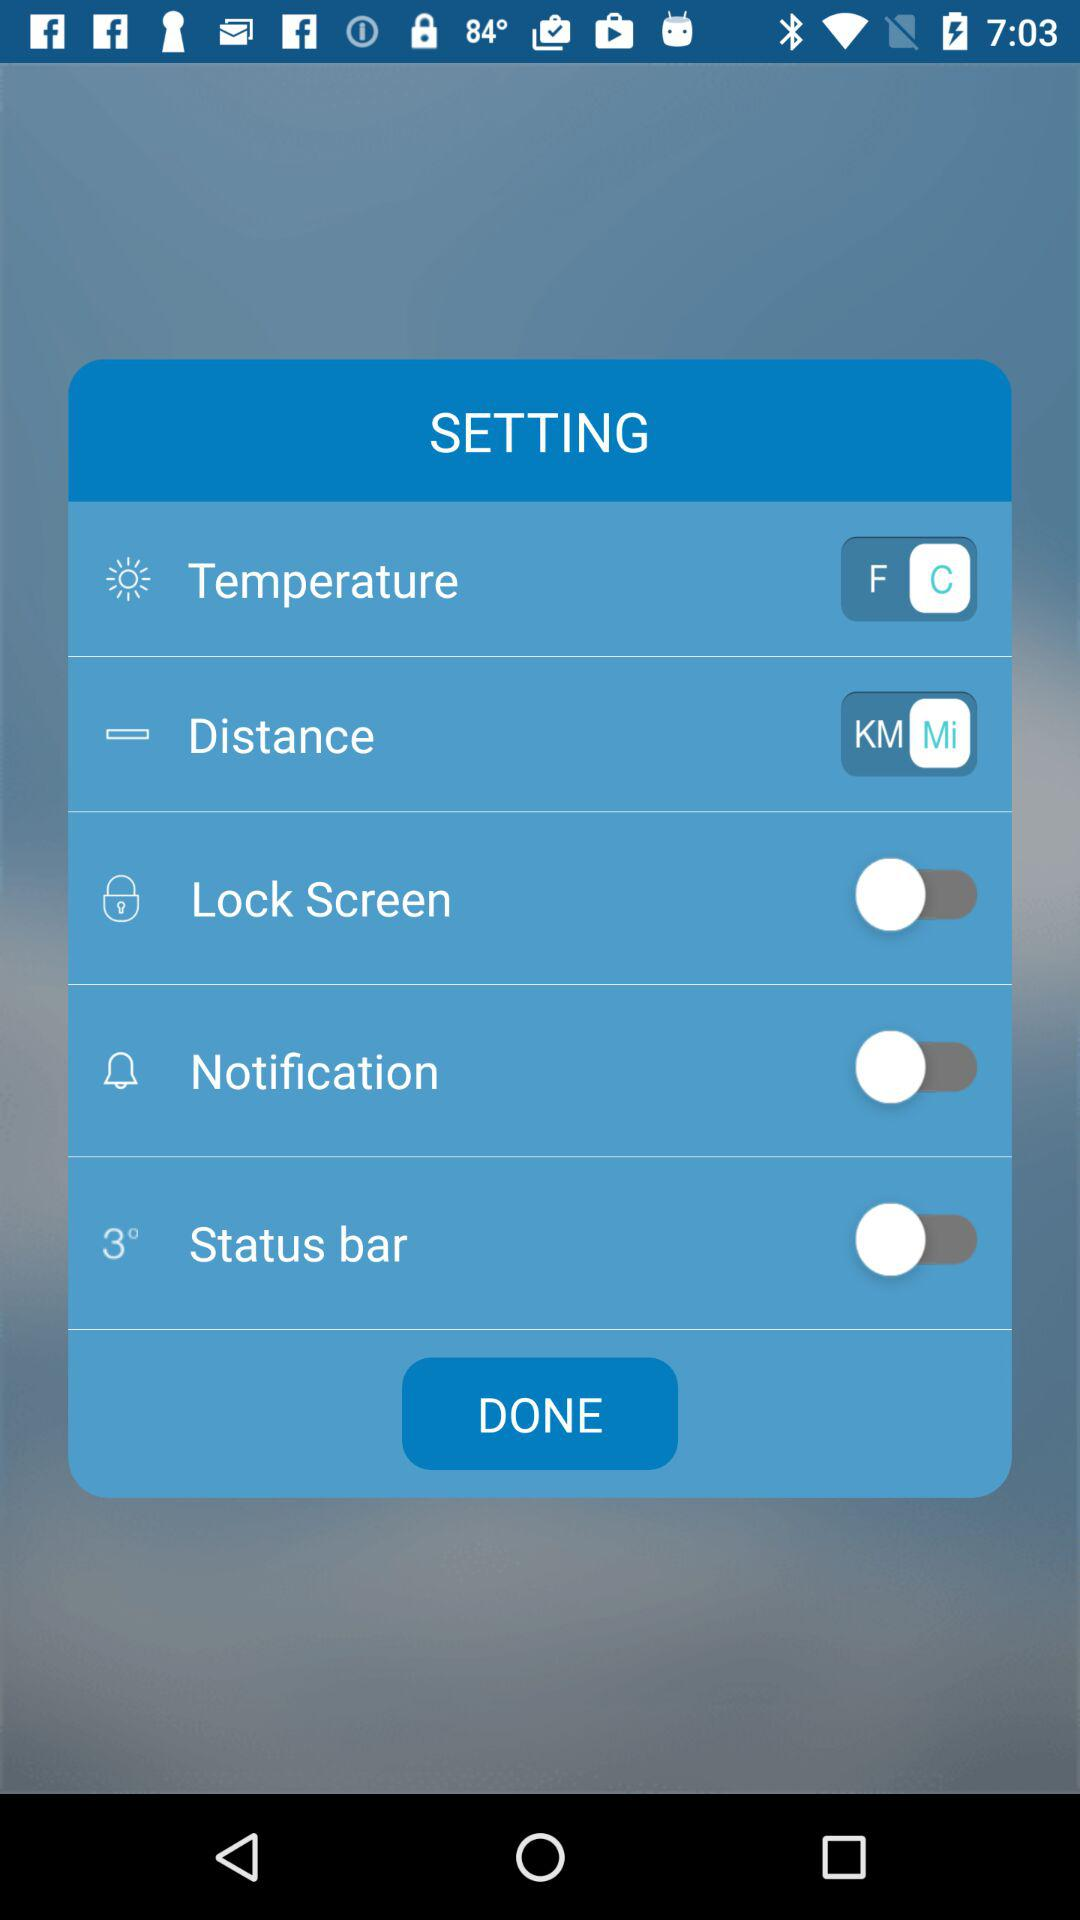What is the status of the "Notification"? The status is "on". 